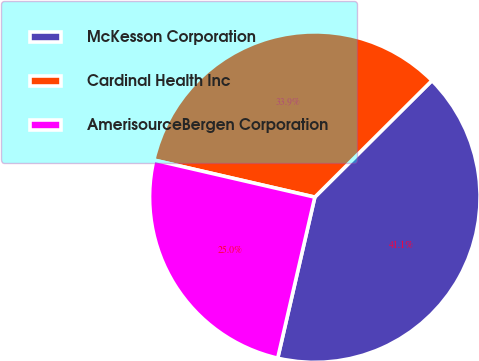Convert chart to OTSL. <chart><loc_0><loc_0><loc_500><loc_500><pie_chart><fcel>McKesson Corporation<fcel>Cardinal Health Inc<fcel>AmerisourceBergen Corporation<nl><fcel>41.07%<fcel>33.93%<fcel>25.0%<nl></chart> 